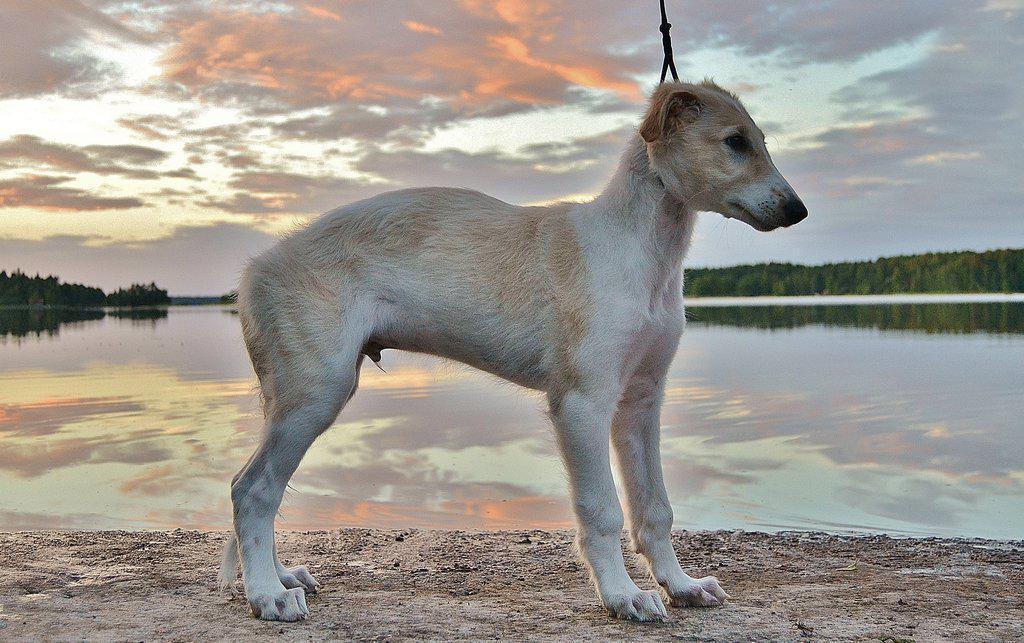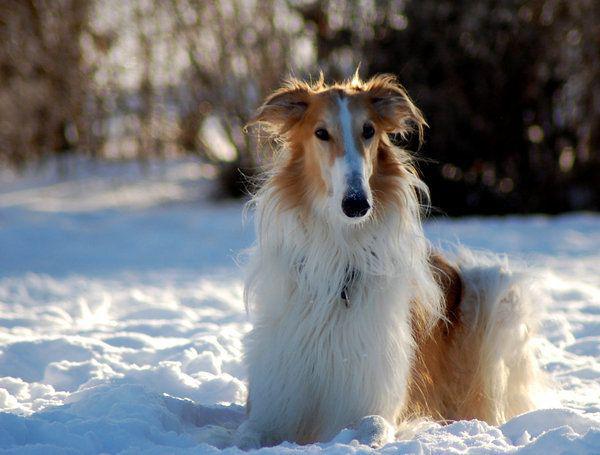The first image is the image on the left, the second image is the image on the right. Given the left and right images, does the statement "One of the dogs is in the snow." hold true? Answer yes or no. Yes. The first image is the image on the left, the second image is the image on the right. Analyze the images presented: Is the assertion "Each image contains one silky haired white afghan hound, and one dog has his head lowered to the left." valid? Answer yes or no. No. 